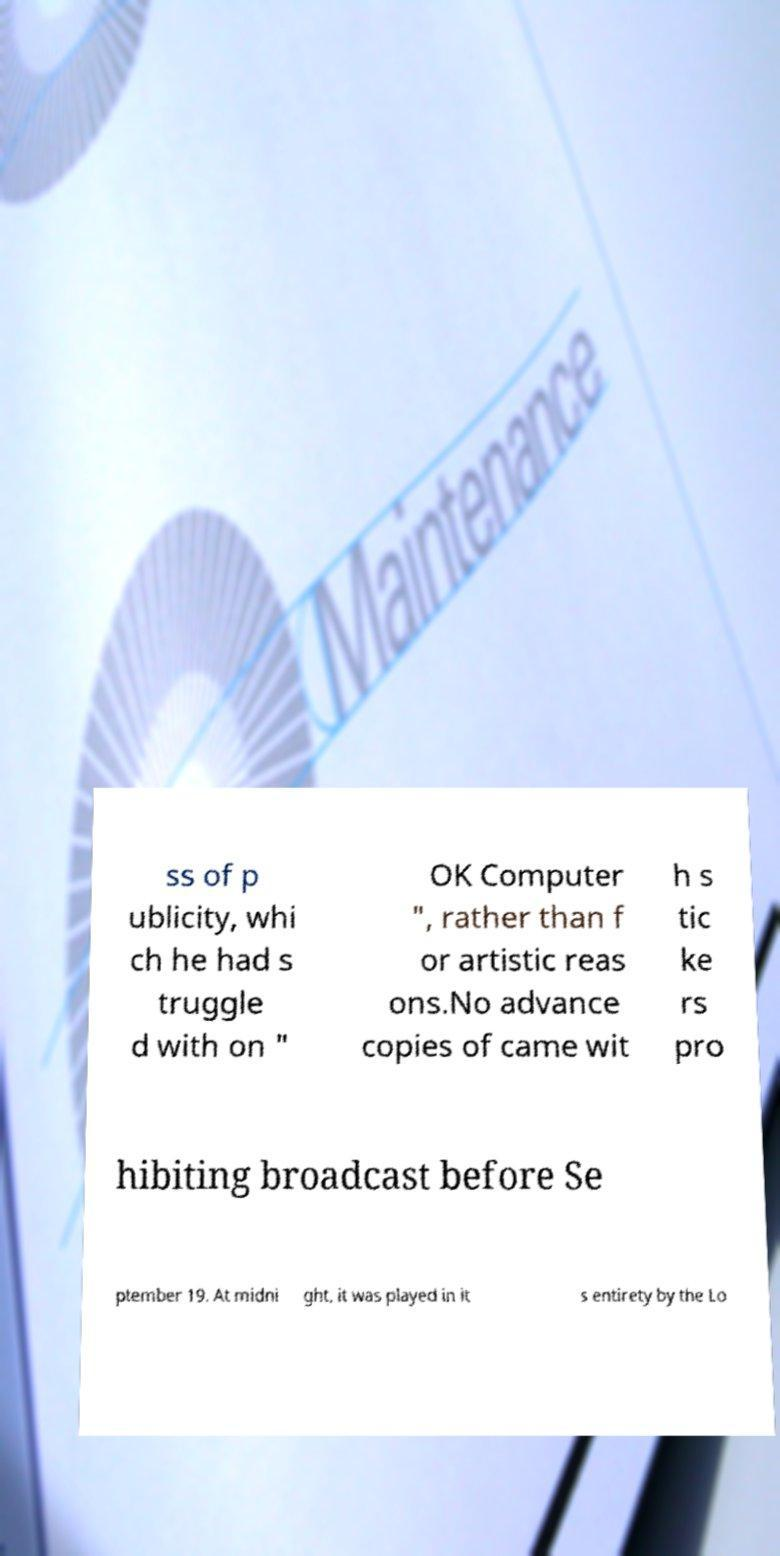Please read and relay the text visible in this image. What does it say? ss of p ublicity, whi ch he had s truggle d with on " OK Computer ", rather than f or artistic reas ons.No advance copies of came wit h s tic ke rs pro hibiting broadcast before Se ptember 19. At midni ght, it was played in it s entirety by the Lo 